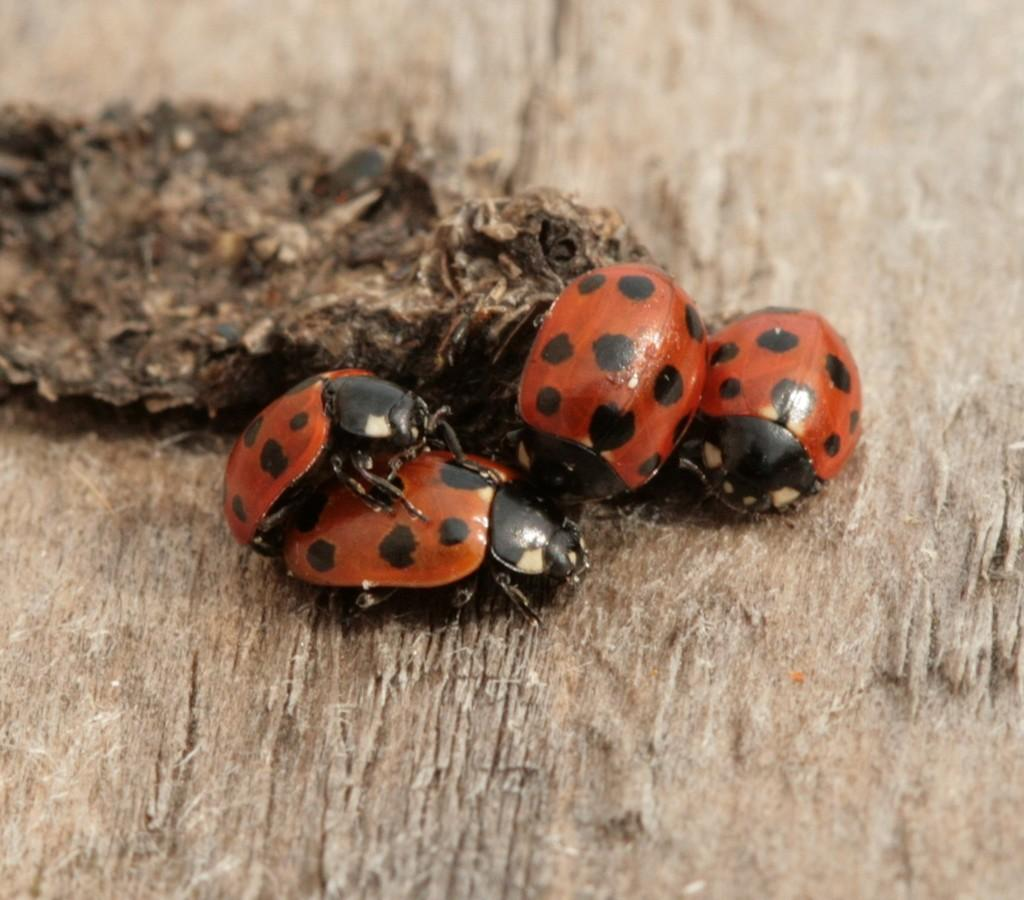What is the color and material of the surface in the image? The surface in the image is brown and made of wood. What object can be seen on the wooden surface? There is a brown and black colored object on the wooden surface. How many insects are present in the image? There are four insects in the image. What colors are the insects? The insects are red and black in color. What type of property is being sold in the image? There is no property being sold in the image; it features a wooden surface with an object and insects. Is there a throne visible in the image? No, there is no throne present in the image. 